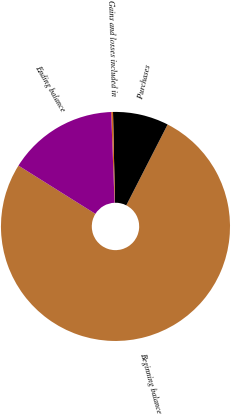Convert chart. <chart><loc_0><loc_0><loc_500><loc_500><pie_chart><fcel>Beginning balance<fcel>Purchases<fcel>Gains and losses included in<fcel>Ending balance<nl><fcel>76.39%<fcel>7.87%<fcel>0.26%<fcel>15.48%<nl></chart> 